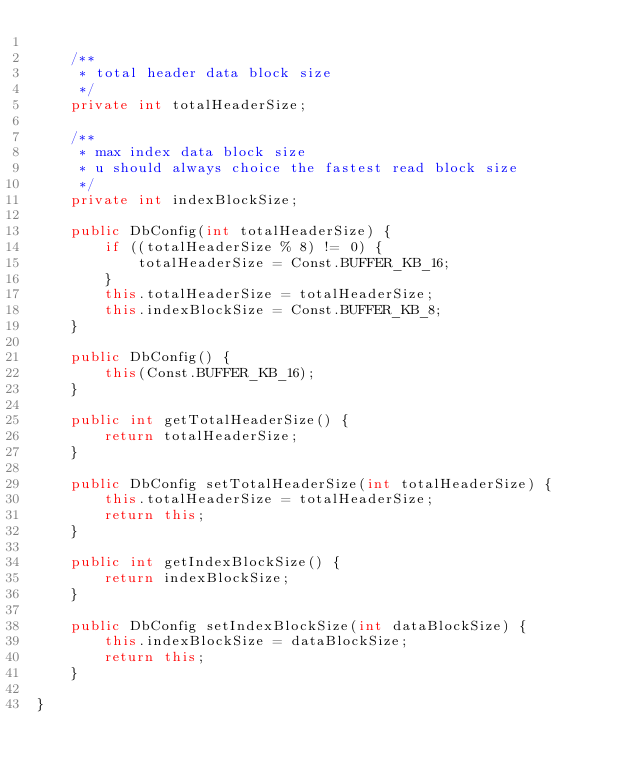<code> <loc_0><loc_0><loc_500><loc_500><_Java_>
    /**
     * total header data block size
     */
    private int totalHeaderSize;

    /**
     * max index data block size
     * u should always choice the fastest read block size
     */
    private int indexBlockSize;

    public DbConfig(int totalHeaderSize) {
        if ((totalHeaderSize % 8) != 0) {
            totalHeaderSize = Const.BUFFER_KB_16;
        }
        this.totalHeaderSize = totalHeaderSize;
        this.indexBlockSize = Const.BUFFER_KB_8;
    }

    public DbConfig() {
        this(Const.BUFFER_KB_16);
    }

    public int getTotalHeaderSize() {
        return totalHeaderSize;
    }

    public DbConfig setTotalHeaderSize(int totalHeaderSize) {
        this.totalHeaderSize = totalHeaderSize;
        return this;
    }

    public int getIndexBlockSize() {
        return indexBlockSize;
    }

    public DbConfig setIndexBlockSize(int dataBlockSize) {
        this.indexBlockSize = dataBlockSize;
        return this;
    }

}
</code> 